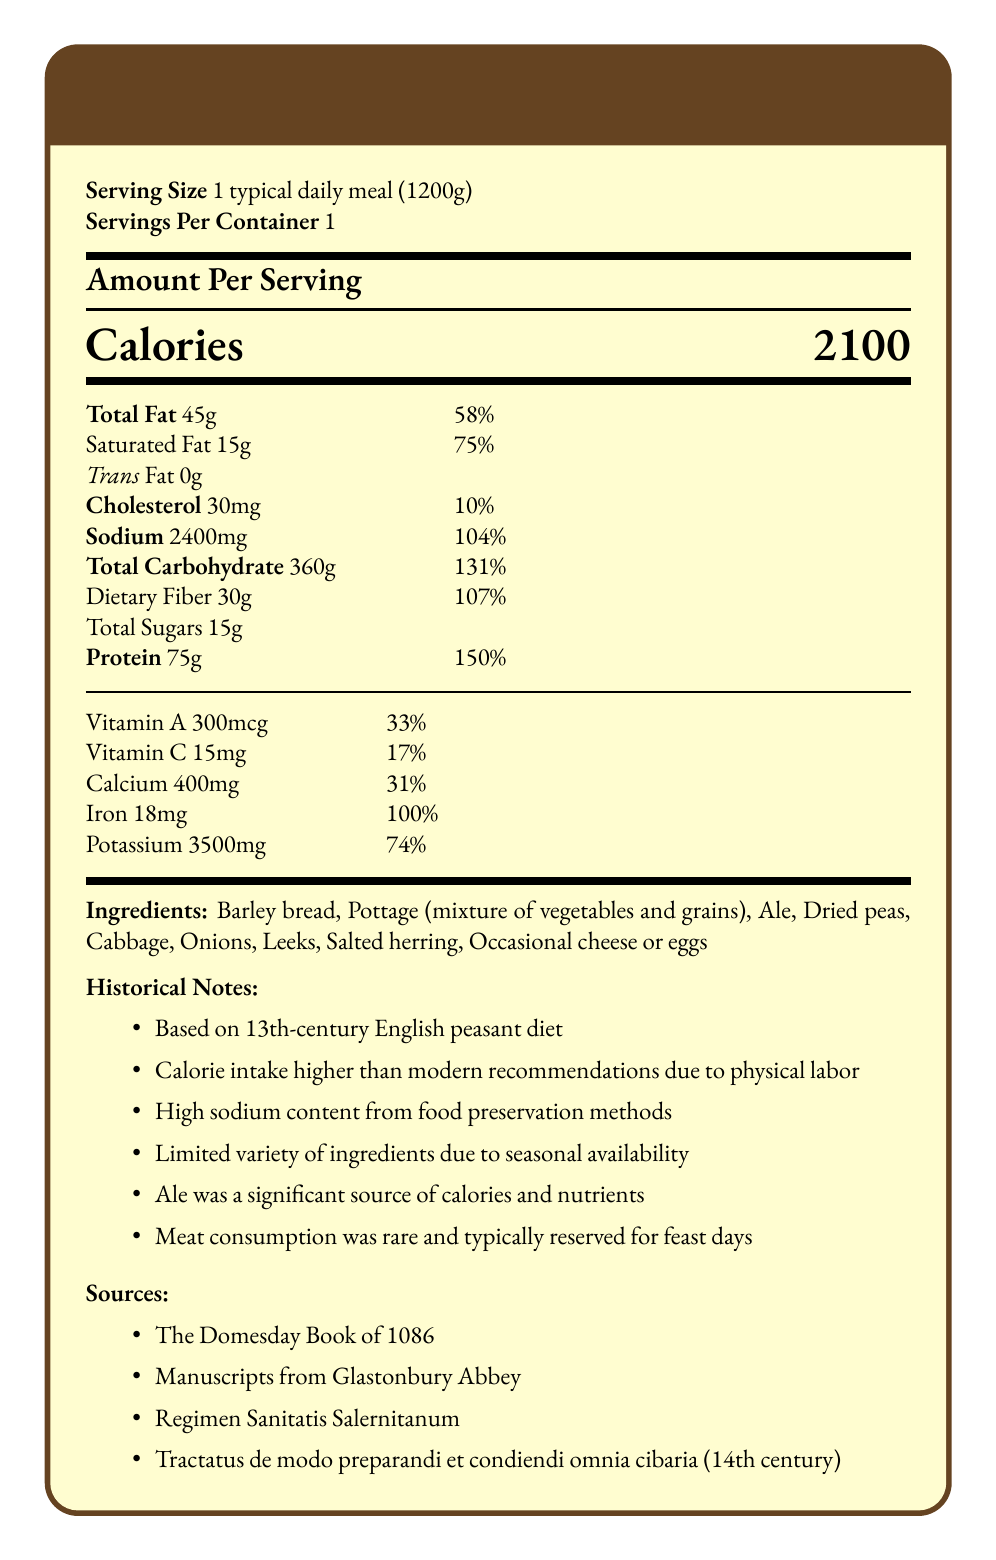who is the document based on? "Based on 13th-century English peasant diet" as stated in the historical notes.
Answer: The 13th-century English peasant diet what is the serving size of the meal? The serving size is listed as "1 typical daily meal (1200g)" in the document.
Answer: 1 typical daily meal (1200g) what is the total fat content per serving? The total fat per serving is indicated as 45 grams.
Answer: 45 grams how many calories does one serving contain? The document specifies that one serving contains 2100 calories.
Answer: 2100 calories What is the daily value percentage of saturated fat? Saturated fat daily value percentage is listed as 75%.
Answer: 75% What are the main ingredients in the meal? The ingredients are explicitly stated in the document.
Answer: Barley bread, Pottage, Ale, Dried peas, Cabbage, Onions, Leeks, Salted herring, Occasional cheese or eggs What is the significance of ale in the diet? A. Source of hydration B. Significant source of calories and nutrients C. Rarely consumed "Ale was a significant source of calories and nutrients" is mentioned in the historical notes.
Answer: B What is the iron content in the meal? A. 10mg B. 18mg C. 30mg D. 45mg The iron content is listed as 18mg in the nutritional information.
Answer: B Is the calorie intake higher or lower than modern recommendations? "Calorie intake higher than modern recommendations due to physical labor" is indicated in the historical notes.
Answer: Higher Is the sodium content high or low? "High sodium content from food preservation methods" is documented in the historical notes.
Answer: High Summarize the document in one sentence. The document provides comprehensive information about the nutritional contents and historical significance of a 13th-century English peasant's diet.
Answer: The document outlines the nutrition facts of a historically accurate 13th-century English peasant's daily meal, detailing its ingredients, nutrient content, and historical context. Which historical texts were used as sources? The sources section lists the historical texts used.
Answer: The Domesday Book of 1086, Manuscripts from Glastonbury Abbey, Regimen Sanitatis Salernitanum, Tractatus de modo preparandi et condiendi omnia cibaria (14th century) What is the percentage of daily value for dietary fiber? Dietary fiber's daily value percentage is listed as 107%.
Answer: 107% Which nutrients have the highest percentage of daily value in this meal? A. Calcium and Iron B. Dietary Fiber and Protein C. Vitamin A and Potassium Protein has a daily value of 150%, and dietary fiber has 107%.
Answer: B What is the potassium content per serving? The potassium content per serving is 3500 mg.
Answer: 3500 milligrams How many meals are in one container according to the document? Serving per container is listed as 1 in the document.
Answer: 1 What was the main reason for the high sodium content? The document notes "High sodium content from food preservation methods" in the historical notes.
Answer: Food preservation methods Does the document provide information on modern health effects of the diet? The document focuses on historical context and nutritional facts, not modern health effects.
Answer: No Which vitamins are listed in the nutrition facts? The listed vitamins are Vitamin A and Vitamin C.
Answer: Vitamin A and Vitamin C What percentage of daily calcium intake does one meal provide? A. 17% B. 31% C. 75% D. 104% The meal provides 31% of the daily calcium intake.
Answer: B 